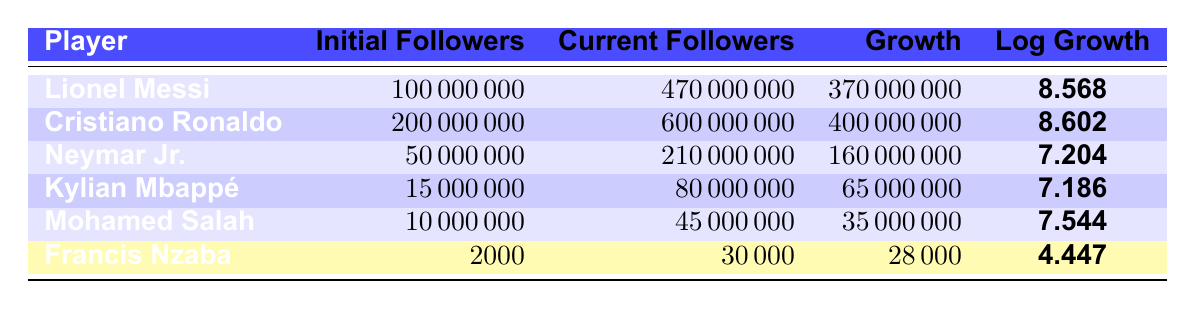What is the initial number of followers for Lionel Messi? By looking in the "Initial Followers" column next to Lionel Messi's name, the value is 100000000.
Answer: 100000000 Which player has the highest growth in followers? The "Growth" column shows 400000000 for Cristiano Ronaldo, which is the largest value compared to others.
Answer: Cristiano Ronaldo What is the logarithm of the growth for Neymar Jr.? Referring to Neymar Jr.'s row in the table, the value in the "Log Growth" column is 7.204.
Answer: 7.204 How many players have more than 100 million current followers? By checking the "Current Followers" column, Lionel Messi (470000000), Cristiano Ronaldo (600000000), and Neymar Jr. (210000000) all have more than 100 million, totaling 3 players.
Answer: 3 Is Francis Nzaba among the players with the highest growth in followers? Comparing the growth values, Francis Nzaba's growth of 28000 is significantly lower than others. Thus, he is not among the highest.
Answer: No What is the average growth in followers for the players listed in the table? Calculating total growth: 370000000 + 400000000 + 160000000 + 65000000 + 35000000 + 28000 = 1000000000. There are 6 players, so the average is 1000000000 / 6 = 166666666.67.
Answer: 166666666.67 Which player has the smallest logarithmic growth? From the "Log Growth" column, Francis Nzaba's value of 4.447 is the smallest compared to others.
Answer: Francis Nzaba How much total growth in followers is recorded for Kylian Mbappé and Mohamed Salah combined? Kylian Mbappé's growth is 65000000 and Mohamed Salah's is 35000000. Adding them gives 65000000 + 35000000 = 100000000.
Answer: 100000000 